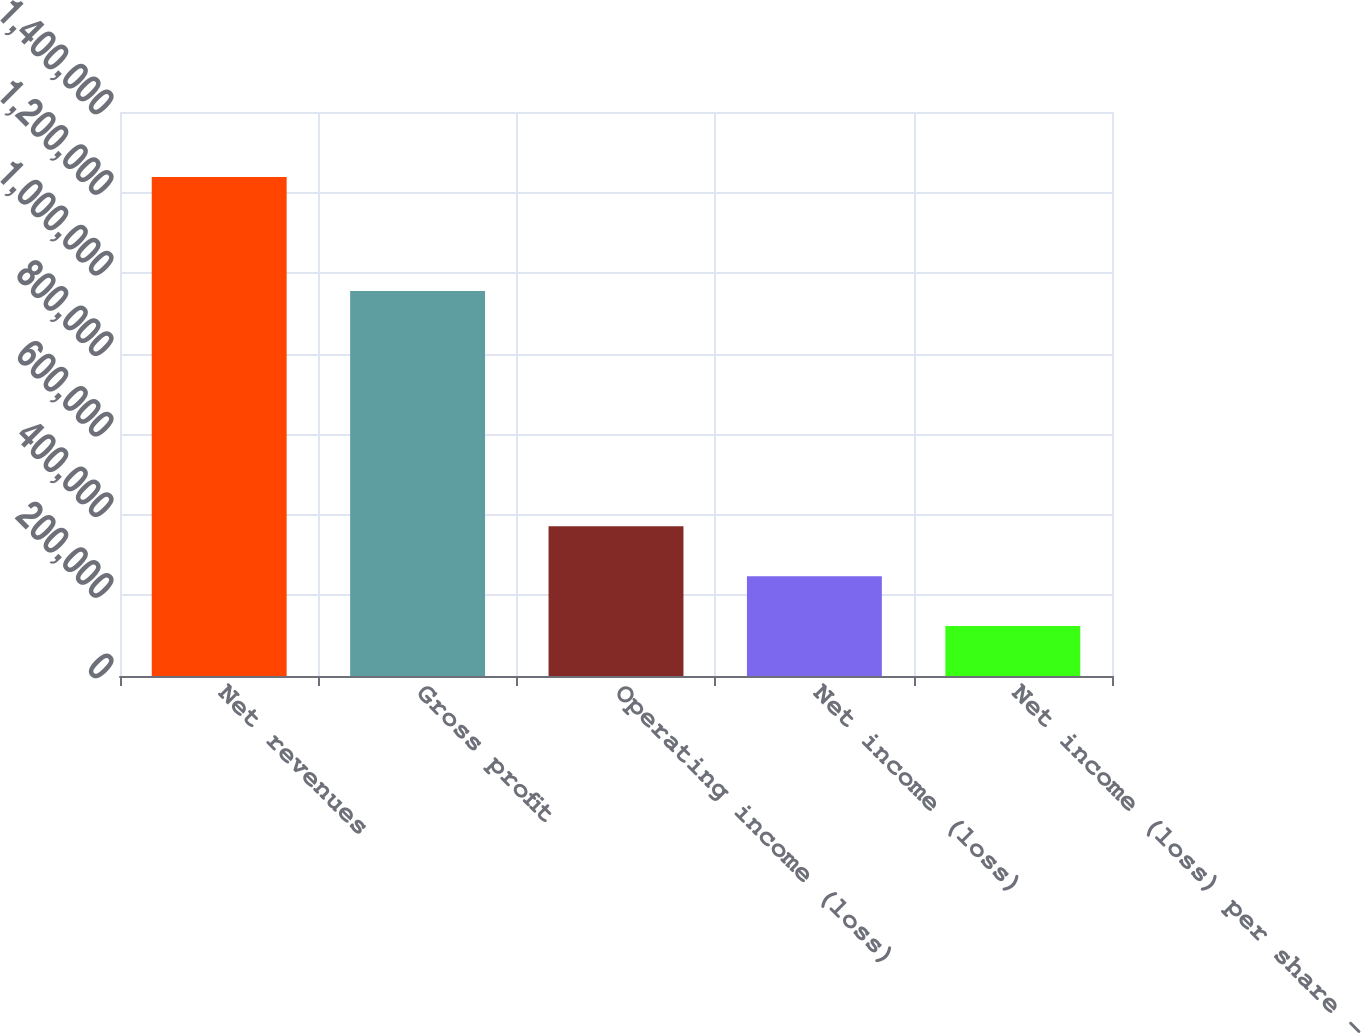Convert chart to OTSL. <chart><loc_0><loc_0><loc_500><loc_500><bar_chart><fcel>Net revenues<fcel>Gross profit<fcel>Operating income (loss)<fcel>Net income (loss)<fcel>Net income (loss) per share -<nl><fcel>1.23856e+06<fcel>955406<fcel>371568<fcel>247712<fcel>123856<nl></chart> 